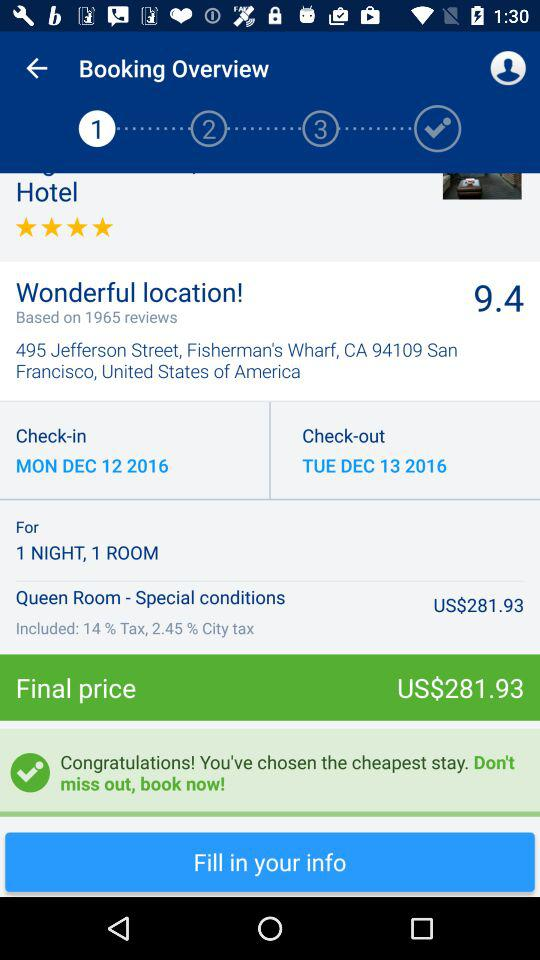What is the final price for booking a room? The final price for booking a room is US$281.93. 